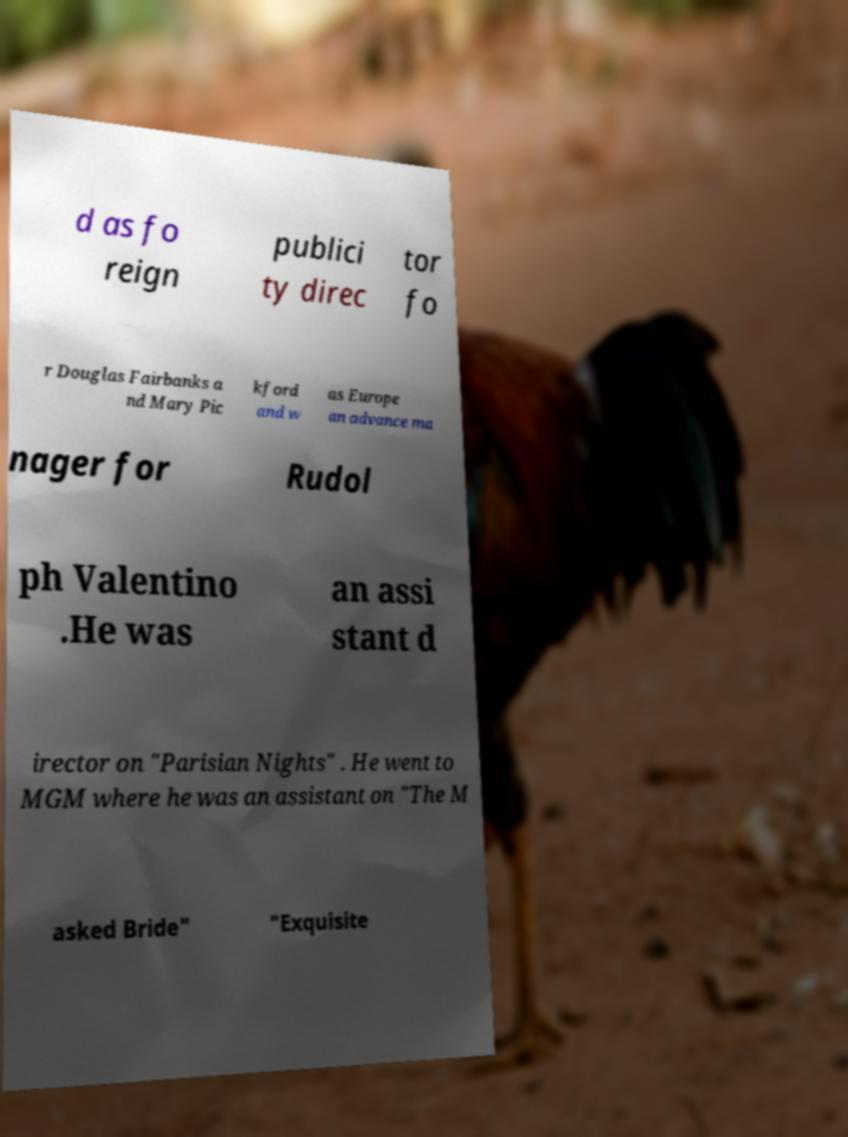Can you accurately transcribe the text from the provided image for me? d as fo reign publici ty direc tor fo r Douglas Fairbanks a nd Mary Pic kford and w as Europe an advance ma nager for Rudol ph Valentino .He was an assi stant d irector on "Parisian Nights" . He went to MGM where he was an assistant on "The M asked Bride" "Exquisite 